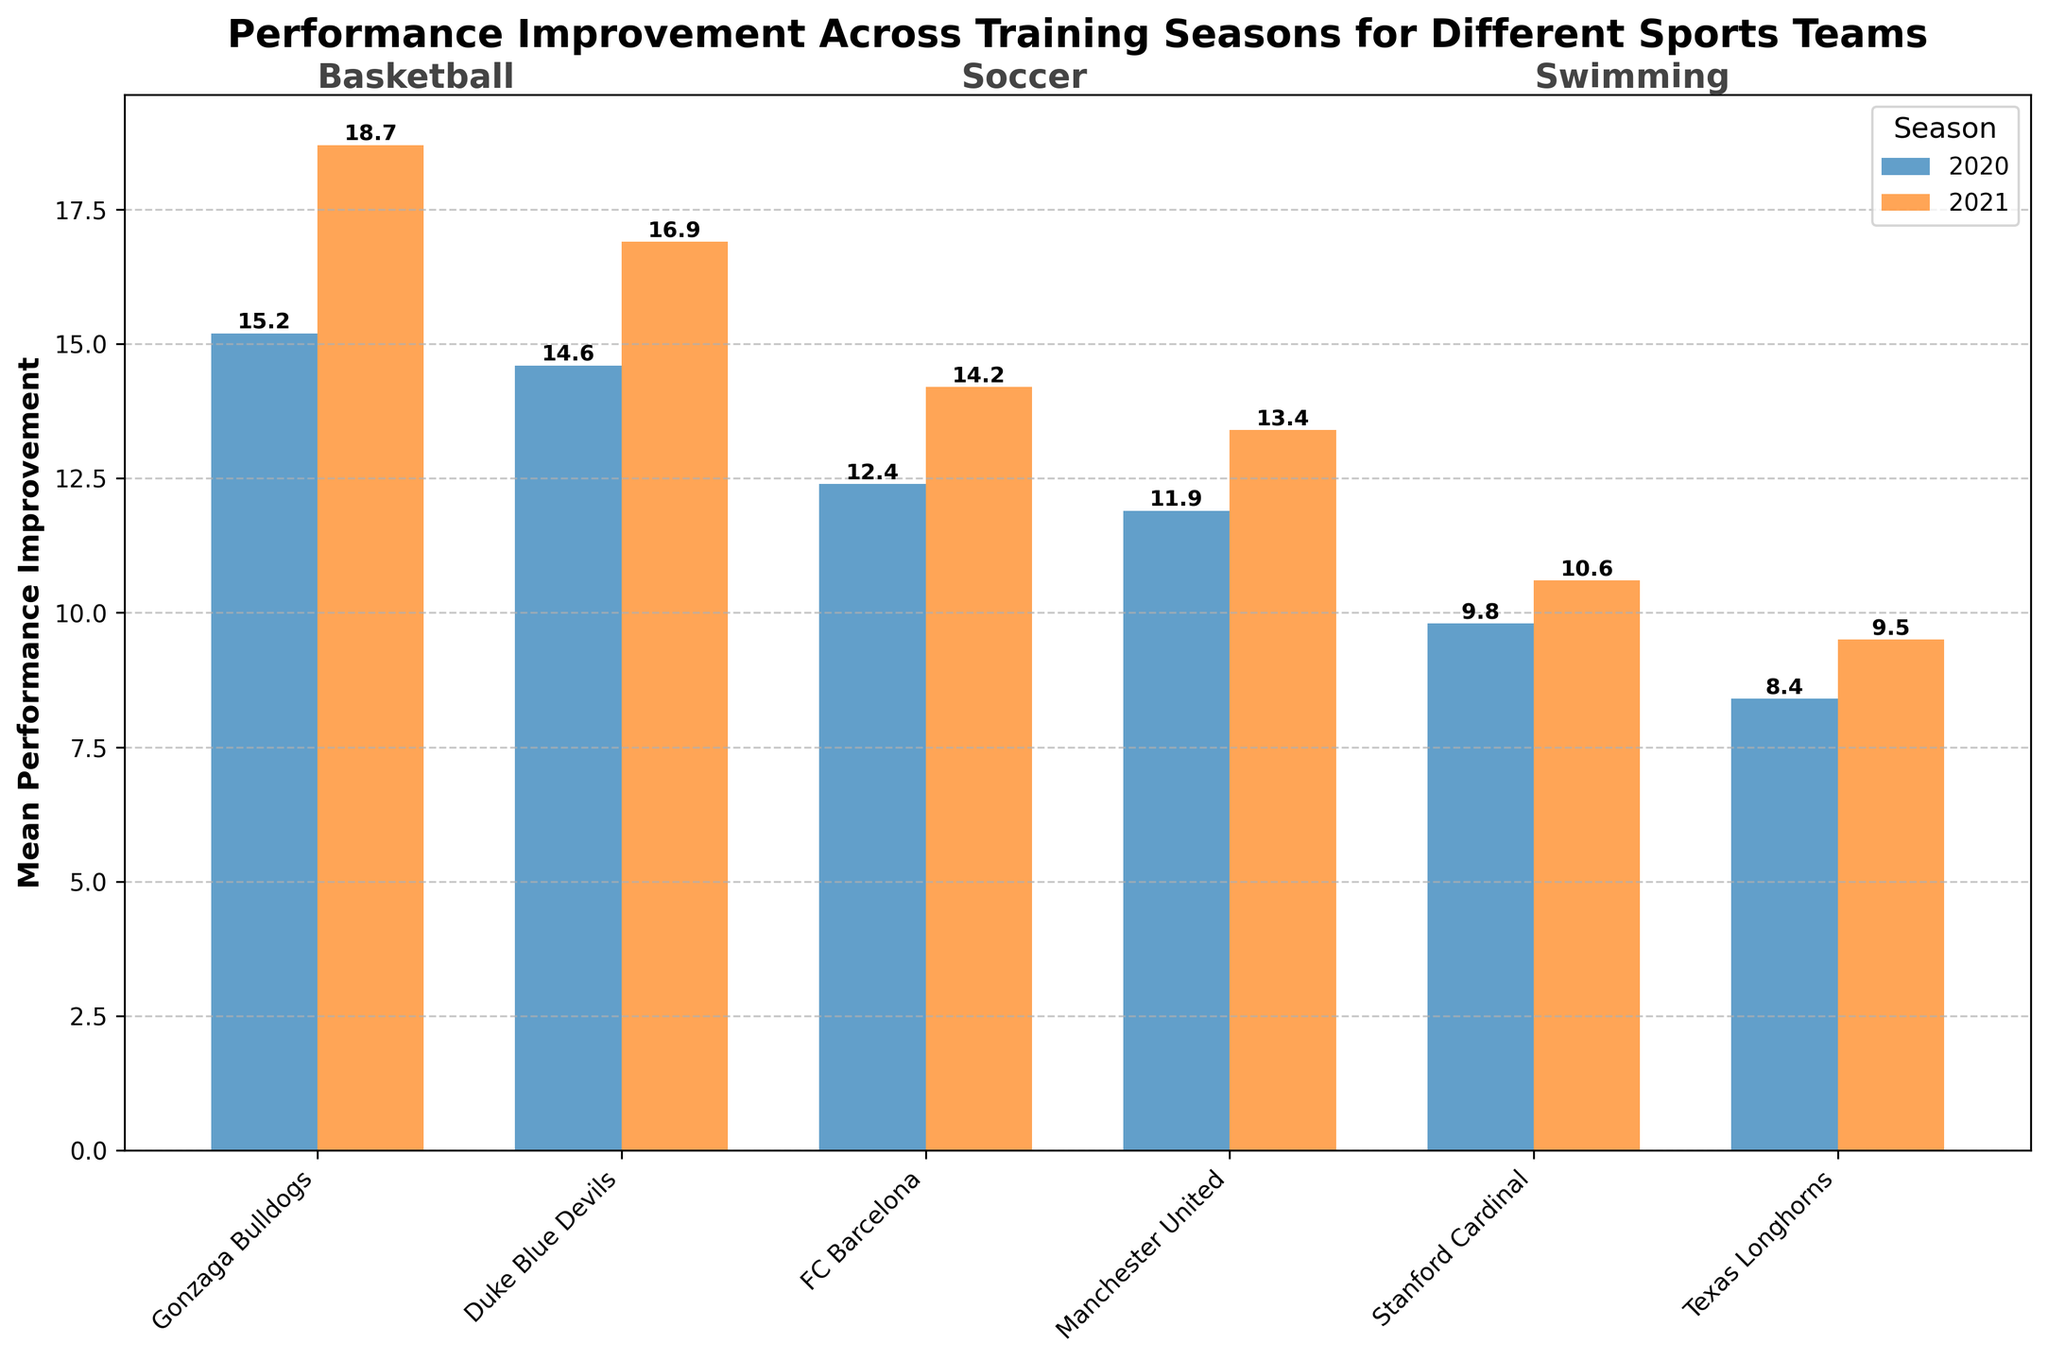What is the title of the bar chart? The title of the bar chart is displayed at the top of the figure. It reads "Performance Improvement Across Training Seasons for Different Sports Teams".
Answer: Performance Improvement Across Training Seasons for Different Sports Teams What does the y-axis represent? The y-axis label describes what it measures. It is labeled "Mean Performance Improvement".
Answer: Mean Performance Improvement How many sports are represented in the bar chart? By counting the different sports labels shown on the plot, we see three sports: Basketball, Soccer, and Swimming.
Answer: 3 Which team had the highest mean performance improvement in 2021? To find this, look at the bar heights for 2021 across all teams. The highest bar represents Gonzaga Bulldogs from Basketball with a value of 18.7.
Answer: Gonzaga Bulldogs What is the difference in mean performance improvement for FC Barcelona between 2020 and 2021? Find the bars for FC Barcelona for the years 2020 and 2021. Subtract the 2020 value (12.4) from the 2021 value (14.2). 14.2 - 12.4 = 1.8.
Answer: 1.8 Which sport showed the least improvement from 2020 to 2021 across teams? Examine the change in bar heights from 2020 to 2021 for each sport. Swimming teams (Stanford Cardinal increased by 0.8, Texas Longhorns increased by 1.1) had the smallest overall increase compared to Basketball and Soccer.
Answer: Swimming What is the mean performance improvement for all teams in 2020? Add up the mean performance improvement values for all teams in 2020 and divide by the number of teams. (15.2 + 14.6 + 12.4 + 11.9 + 9.8 + 8.4) / 6 = 12.05.
Answer: 12.05 Which team showed the greatest reduction in the standard deviation of performance improvement from 2020 to 2021? Compare the standard deviation values for each team from 2020 to 2021. All teams increased except Stanford Cardinal (2.0 - 1.5) and FC Barcelona (2.0 - 1.8). FC Barcelona had the greatest reduction by 0.2.
Answer: FC Barcelona What is the range of the mean performance improvement for Basketball teams in 2021? Identify the mean performance improvements for Basketball teams in 2021: Gonzaga Bulldogs (18.7) and Duke Blue Devils (16.9). The range is the difference between the highest and lowest values. 18.7 - 16.9 = 1.8.
Answer: 1.8 Which team had the smallest standard deviation in both 2020 and 2021? Look for the smallest standard deviation values in each year. Texas Longhorns had the smallest in both years: 1.3 in 2020 and 1.4 in 2021.
Answer: Texas Longhorns 